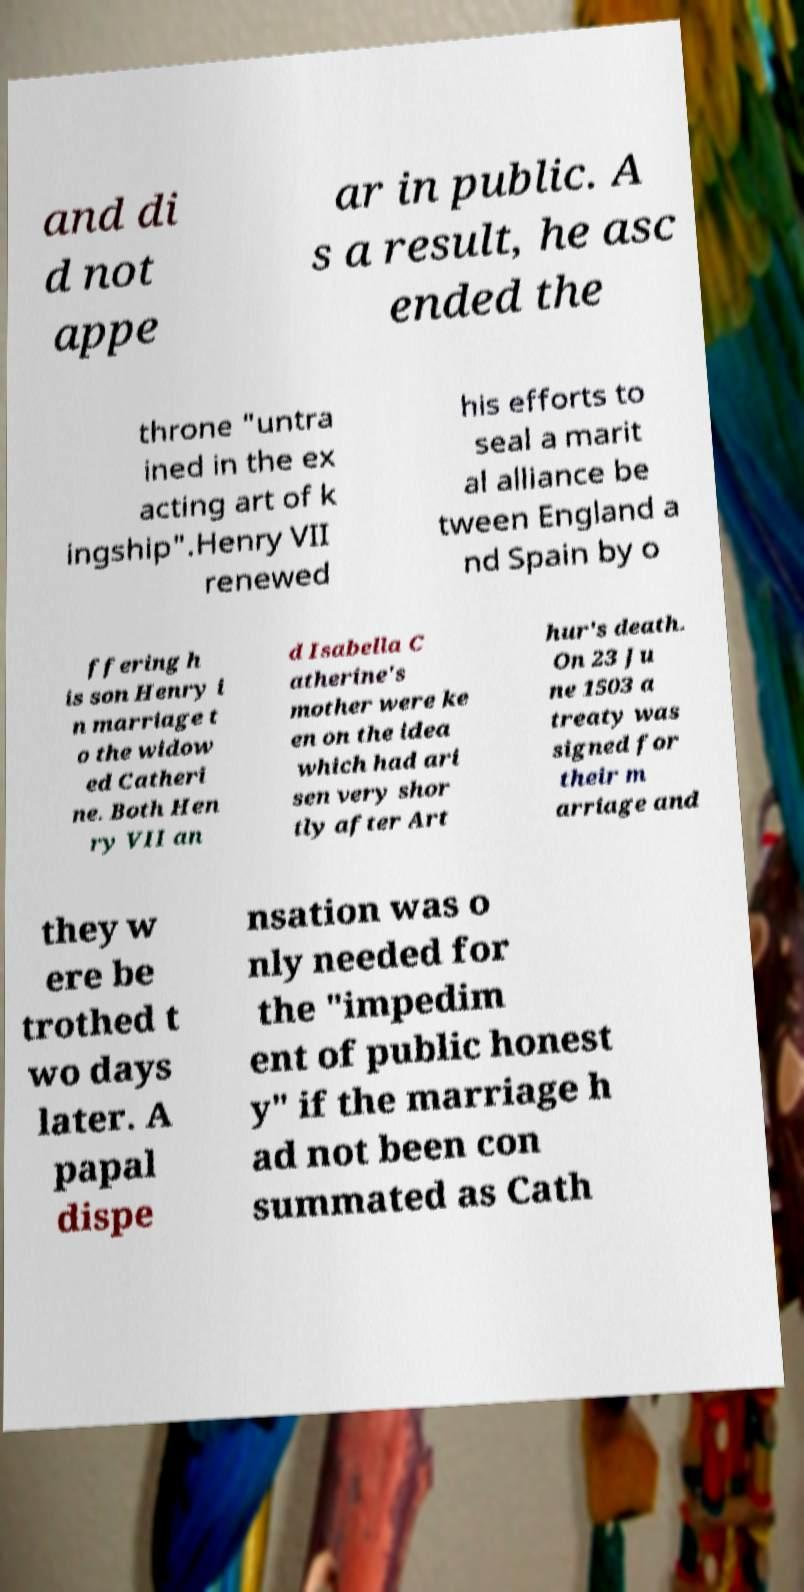Please identify and transcribe the text found in this image. and di d not appe ar in public. A s a result, he asc ended the throne "untra ined in the ex acting art of k ingship".Henry VII renewed his efforts to seal a marit al alliance be tween England a nd Spain by o ffering h is son Henry i n marriage t o the widow ed Catheri ne. Both Hen ry VII an d Isabella C atherine's mother were ke en on the idea which had ari sen very shor tly after Art hur's death. On 23 Ju ne 1503 a treaty was signed for their m arriage and they w ere be trothed t wo days later. A papal dispe nsation was o nly needed for the "impedim ent of public honest y" if the marriage h ad not been con summated as Cath 